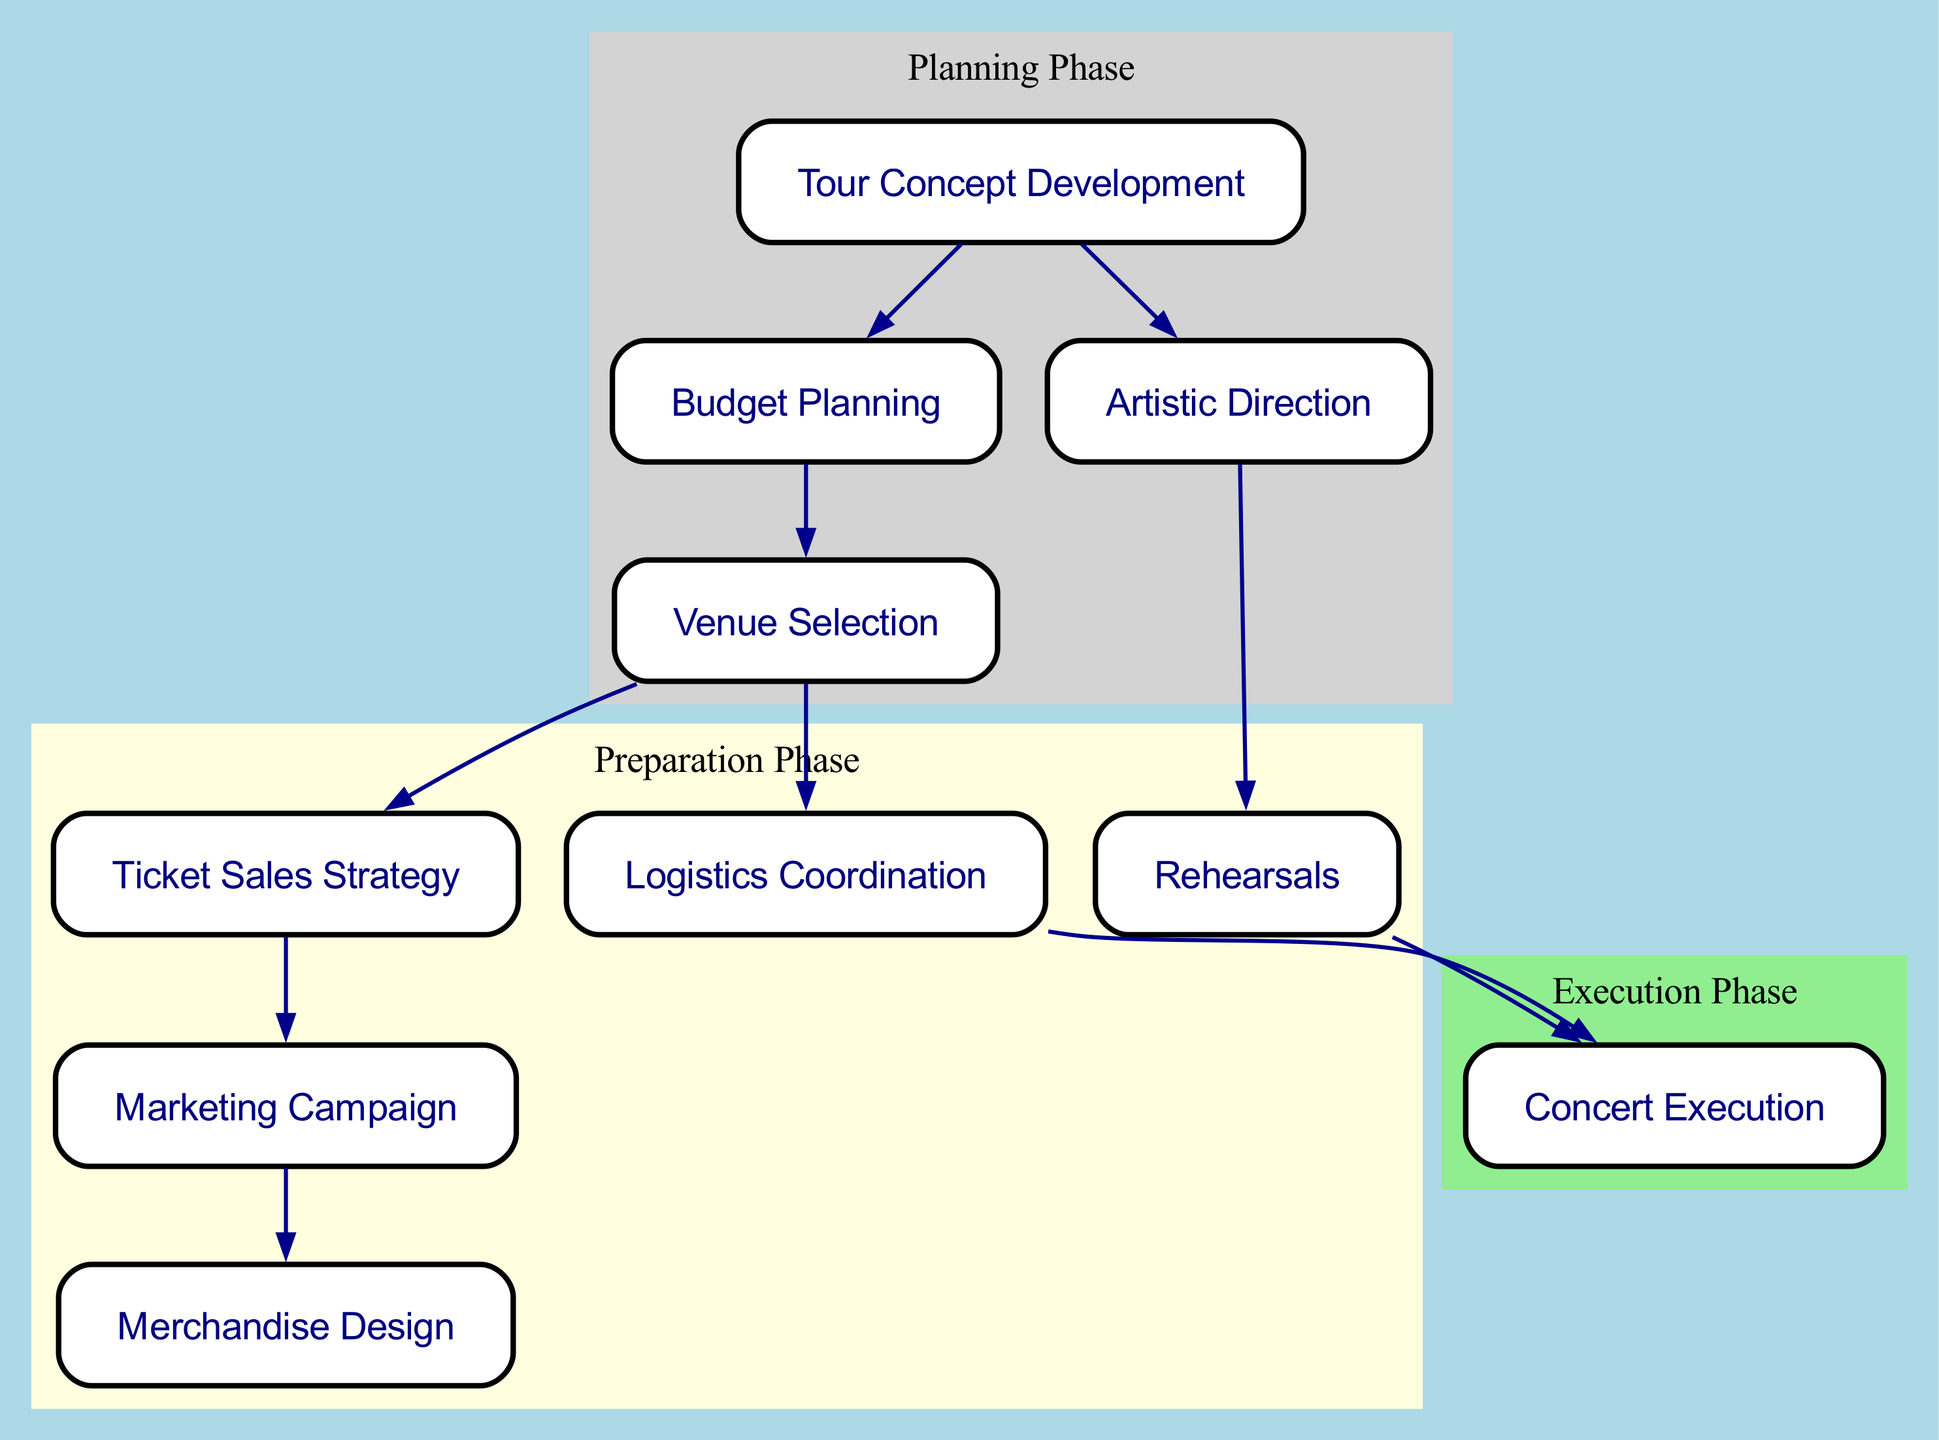What is the first step in organizing a Snow Man concert tour? The diagram shows "Tour Concept Development" at the beginning, indicating it is the first step in the process.
Answer: Tour Concept Development How many nodes are present in the diagram? By counting each distinct process represented in the diagram, we find there are ten nodes listed.
Answer: 10 What is the last step in the concert organization process? The final node in the flow of the diagram is "Concert Execution," which indicates it is the last step.
Answer: Concert Execution Which phase includes "Marketing Campaign"? "Marketing Campaign" is placed within the "Preparation Phase" as indicated by the cluster that groups related processes.
Answer: Preparation Phase How many edges connect "Rehearsals" to other nodes? The diagram shows two edges originating from "Rehearsals," connecting it to "Concert Execution."
Answer: 2 What two nodes are directly linked to "Budget Planning"? The diagram displays edges leading from "Budget Planning" to both "Venue Selection" and "Tour Concept Development."
Answer: Venue Selection, Tour Concept Development Which node is linked to both "Ticket Sales Strategy" and "Logistics Coordination"? The diagram indicates that "Venue Selection" connects to both "Ticket Sales Strategy" and "Logistics Coordination," making it the linking node.
Answer: Venue Selection What is the color representing the "Execution Phase"? The "Execution Phase" is represented by the color light green in the diagram.
Answer: Light green What process follows "Artistic Direction"? According to the diagram, the process following "Artistic Direction" is "Rehearsals."
Answer: Rehearsals Which two nodes must be completed before "Concert Execution"? Before "Concert Execution," both "Rehearsals" and "Logistics Coordination" must be completed, as indicated by the edges leading to "Concert Execution."
Answer: Rehearsals, Logistics Coordination 